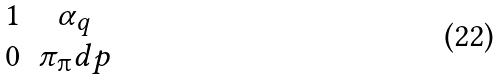Convert formula to latex. <formula><loc_0><loc_0><loc_500><loc_500>\begin{matrix} 1 & \alpha _ { q } \\ 0 & \pi _ { \i } d { p } \end{matrix}</formula> 